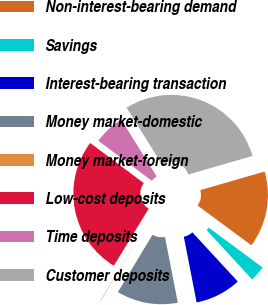Convert chart. <chart><loc_0><loc_0><loc_500><loc_500><pie_chart><fcel>Non-interest-bearing demand<fcel>Savings<fcel>Interest-bearing transaction<fcel>Money market-domestic<fcel>Money market-foreign<fcel>Low-cost deposits<fcel>Time deposits<fcel>Customer deposits<nl><fcel>14.62%<fcel>2.99%<fcel>8.8%<fcel>11.71%<fcel>0.08%<fcel>26.5%<fcel>5.9%<fcel>29.4%<nl></chart> 